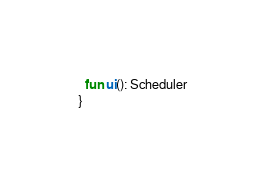<code> <loc_0><loc_0><loc_500><loc_500><_Kotlin_>  fun ui(): Scheduler
}
</code> 